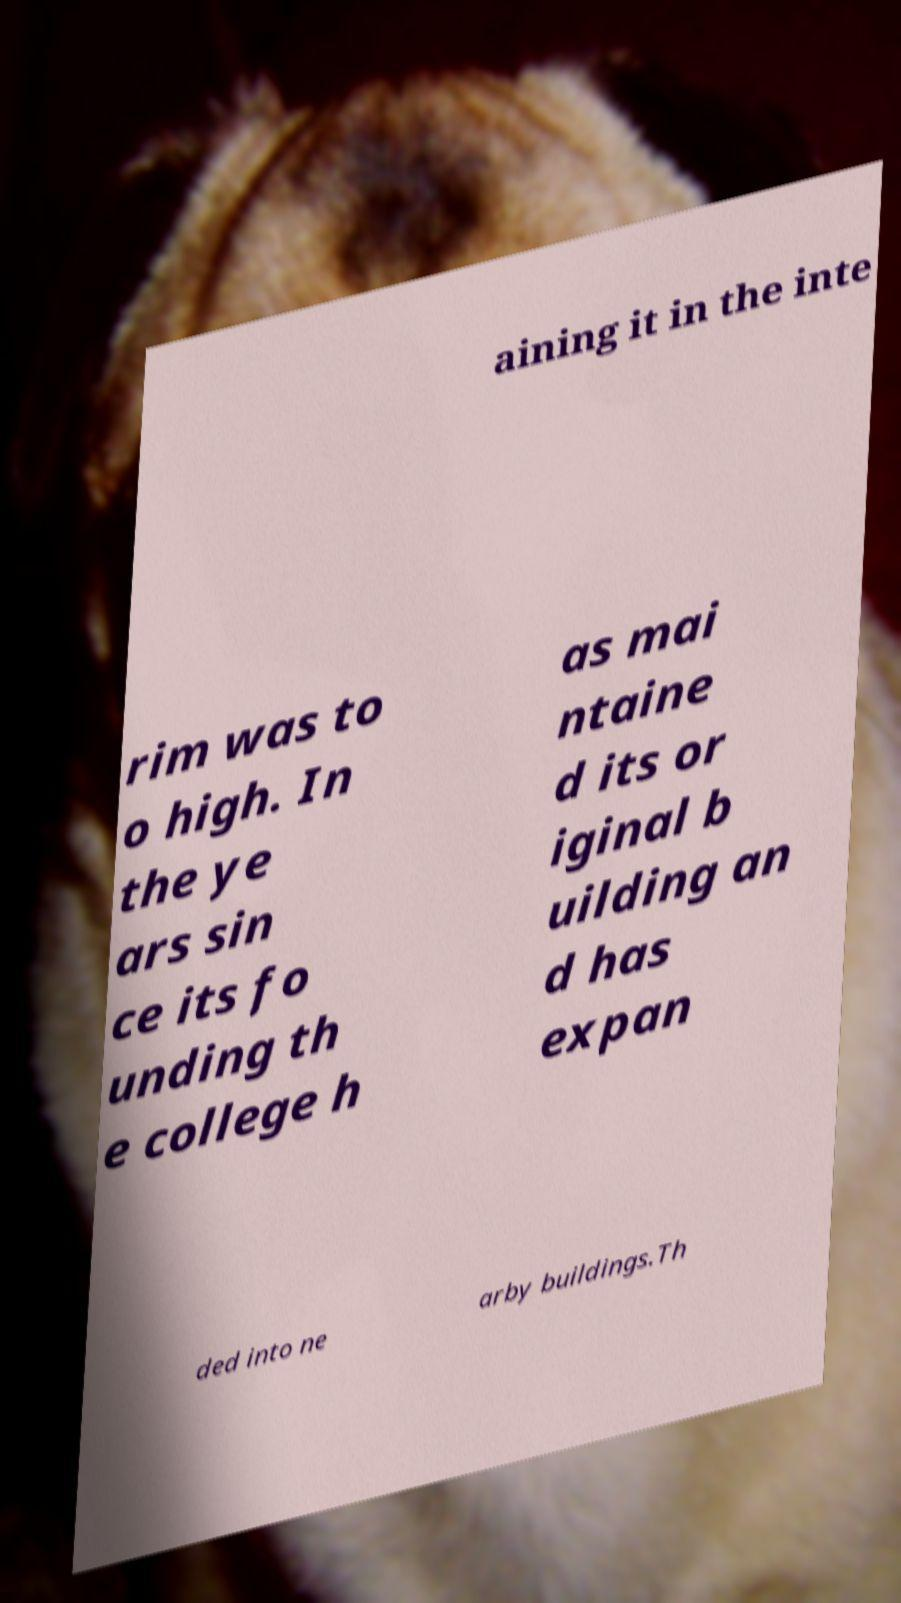Could you assist in decoding the text presented in this image and type it out clearly? aining it in the inte rim was to o high. In the ye ars sin ce its fo unding th e college h as mai ntaine d its or iginal b uilding an d has expan ded into ne arby buildings.Th 